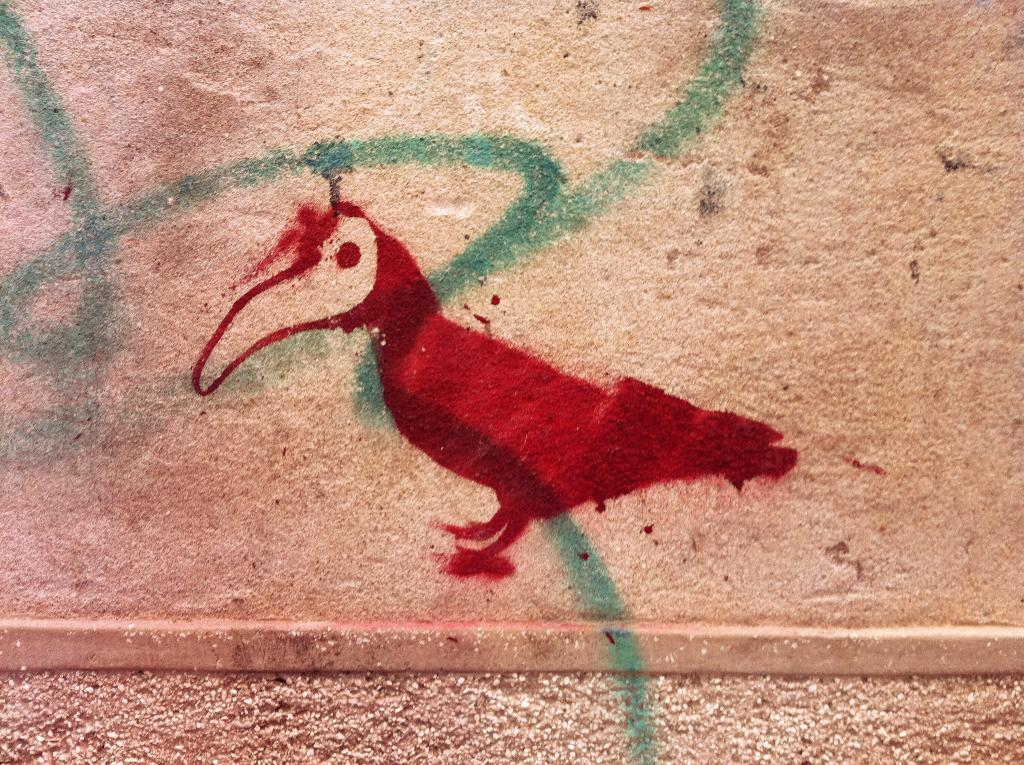What is depicted in the painting on the wall? There is a painting of a bird on the wall. What color is the painting? The painting is red in color. How many ladybugs are present on the painting? There are no ladybugs present on the painting; it features a bird. What type of vase is depicted in the painting? There is no vase depicted in the painting; it features a bird. 